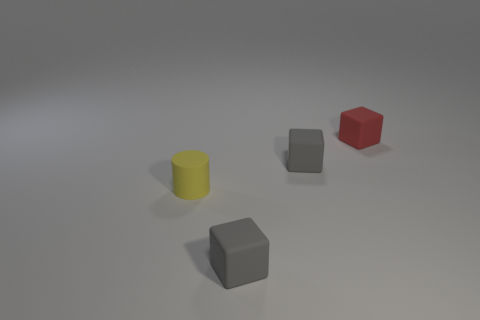There is a gray block to the right of the rubber block that is in front of the tiny cylinder; what number of tiny red matte things are on the left side of it?
Your answer should be compact. 0. There is a gray object behind the cylinder; what is its shape?
Your response must be concise. Cube. What number of other things are there of the same material as the small yellow object
Your response must be concise. 3. Are there fewer small red things to the left of the red block than small gray rubber objects that are in front of the small rubber cylinder?
Your answer should be compact. Yes. Are there fewer rubber blocks on the left side of the yellow cylinder than big purple matte balls?
Provide a succinct answer. No. Are there any other things that are the same shape as the yellow rubber object?
Provide a short and direct response. No. Are there fewer yellow matte cylinders than purple metal blocks?
Make the answer very short. No. There is a tiny thing that is behind the matte cylinder and in front of the red block; what material is it?
Your response must be concise. Rubber. There is a small gray thing behind the cylinder; are there any tiny red blocks that are on the left side of it?
Keep it short and to the point. No. How many objects are either red blocks or cyan metallic spheres?
Provide a short and direct response. 1. 